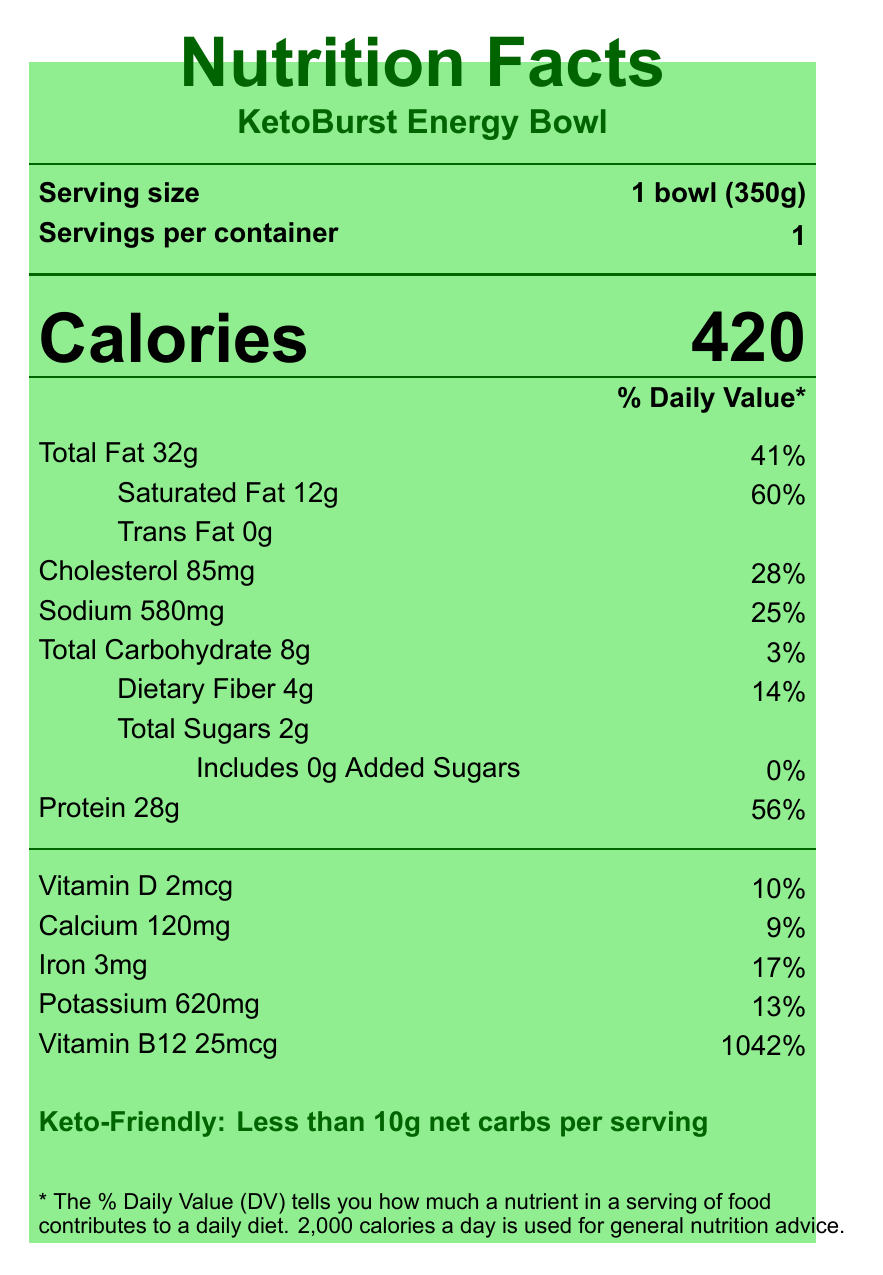what is the serving size of the KetoBurst Energy Bowl? The serving size is mentioned as "1 bowl (350g)" on the document.
Answer: 1 bowl (350g) how many calories are there in one serving? The calories per serving are clearly listed as "420".
Answer: 420 how much total fat is in one serving? The document specifies the total fat as 32 grams.
Answer: 32 grams what is the percentage of daily value for saturated fat? The percentage of daily value for saturated fat is given as 60%.
Answer: 60% how much protein does the KetoBurst Energy Bowl contain? The document lists the protein content as 28 grams.
Answer: 28 grams how much dietary fiber is in one serving? The document mentions that there are 4 grams of dietary fiber.
Answer: 4 grams what is the amount of added sugars in the product? The document indicates that there are 0 grams of added sugars.
Answer: 0 grams how many milligrams of sodium does one serving contain? A. 500mg B. 580mg C. 620mg The sodium content per serving is listed as 580 milligrams.
Answer: B. 580mg what percentage of the daily value for calcium does one serving provide? A. 8% B. 9% C. 10% D. 11% The daily value percentage for calcium is indicated as 9%.
Answer: B. 9% does the product contain any trans fat? The document lists 0 grams of trans fat, indicating the product does not contain any trans fat.
Answer: No is the product labeled keto-friendly? The document specifically mentions "Keto-Friendly: Less than 10g net carbs per serving".
Answer: Yes is the KetoBurst Energy Bowl suitable for people with milk allergies? The document lists "Milk" under allergens, making it unsuitable for people with milk allergies.
Answer: No which of the following is an ingredient in the KetoBurst Energy Bowl? A. Brown Rice B. Organic Cauliflower Rice C. Palm Oil The ingredients list includes "Organic Cauliflower Rice".
Answer: B. Organic Cauliflower Rice describe the main idea of the document. The document details the nutritional facts, claims about keto-friendliness, weight-loss, and mental clarity benefits, and relevant product information.
Answer: The document provides detailed nutritional information about the KetoBurst Energy Bowl, emphasizing its suitability for a keto diet with high protein, healthy fats, and low carbohydrates, promoting weight loss and mental clarity. how should the KetoBurst Energy Bowl be prepared for best results? The preparation instructions indicate microwaving for 3-4 minutes or heating in a skillet for best results.
Answer: Microwave for 3-4 minutes or heat in a skillet how much Vitamin B12 is in one serving, and how does it compare to the daily value percentage? The document shows that one serving contains 25mcg of Vitamin B12, which is 1042% of the daily value.
Answer: 25mcg, 1042% what is the brand story behind KetoBurst? The document does not provide sufficient details about the brand story beyond mentioning it was created by a successful side hustler.
Answer: Not enough information 